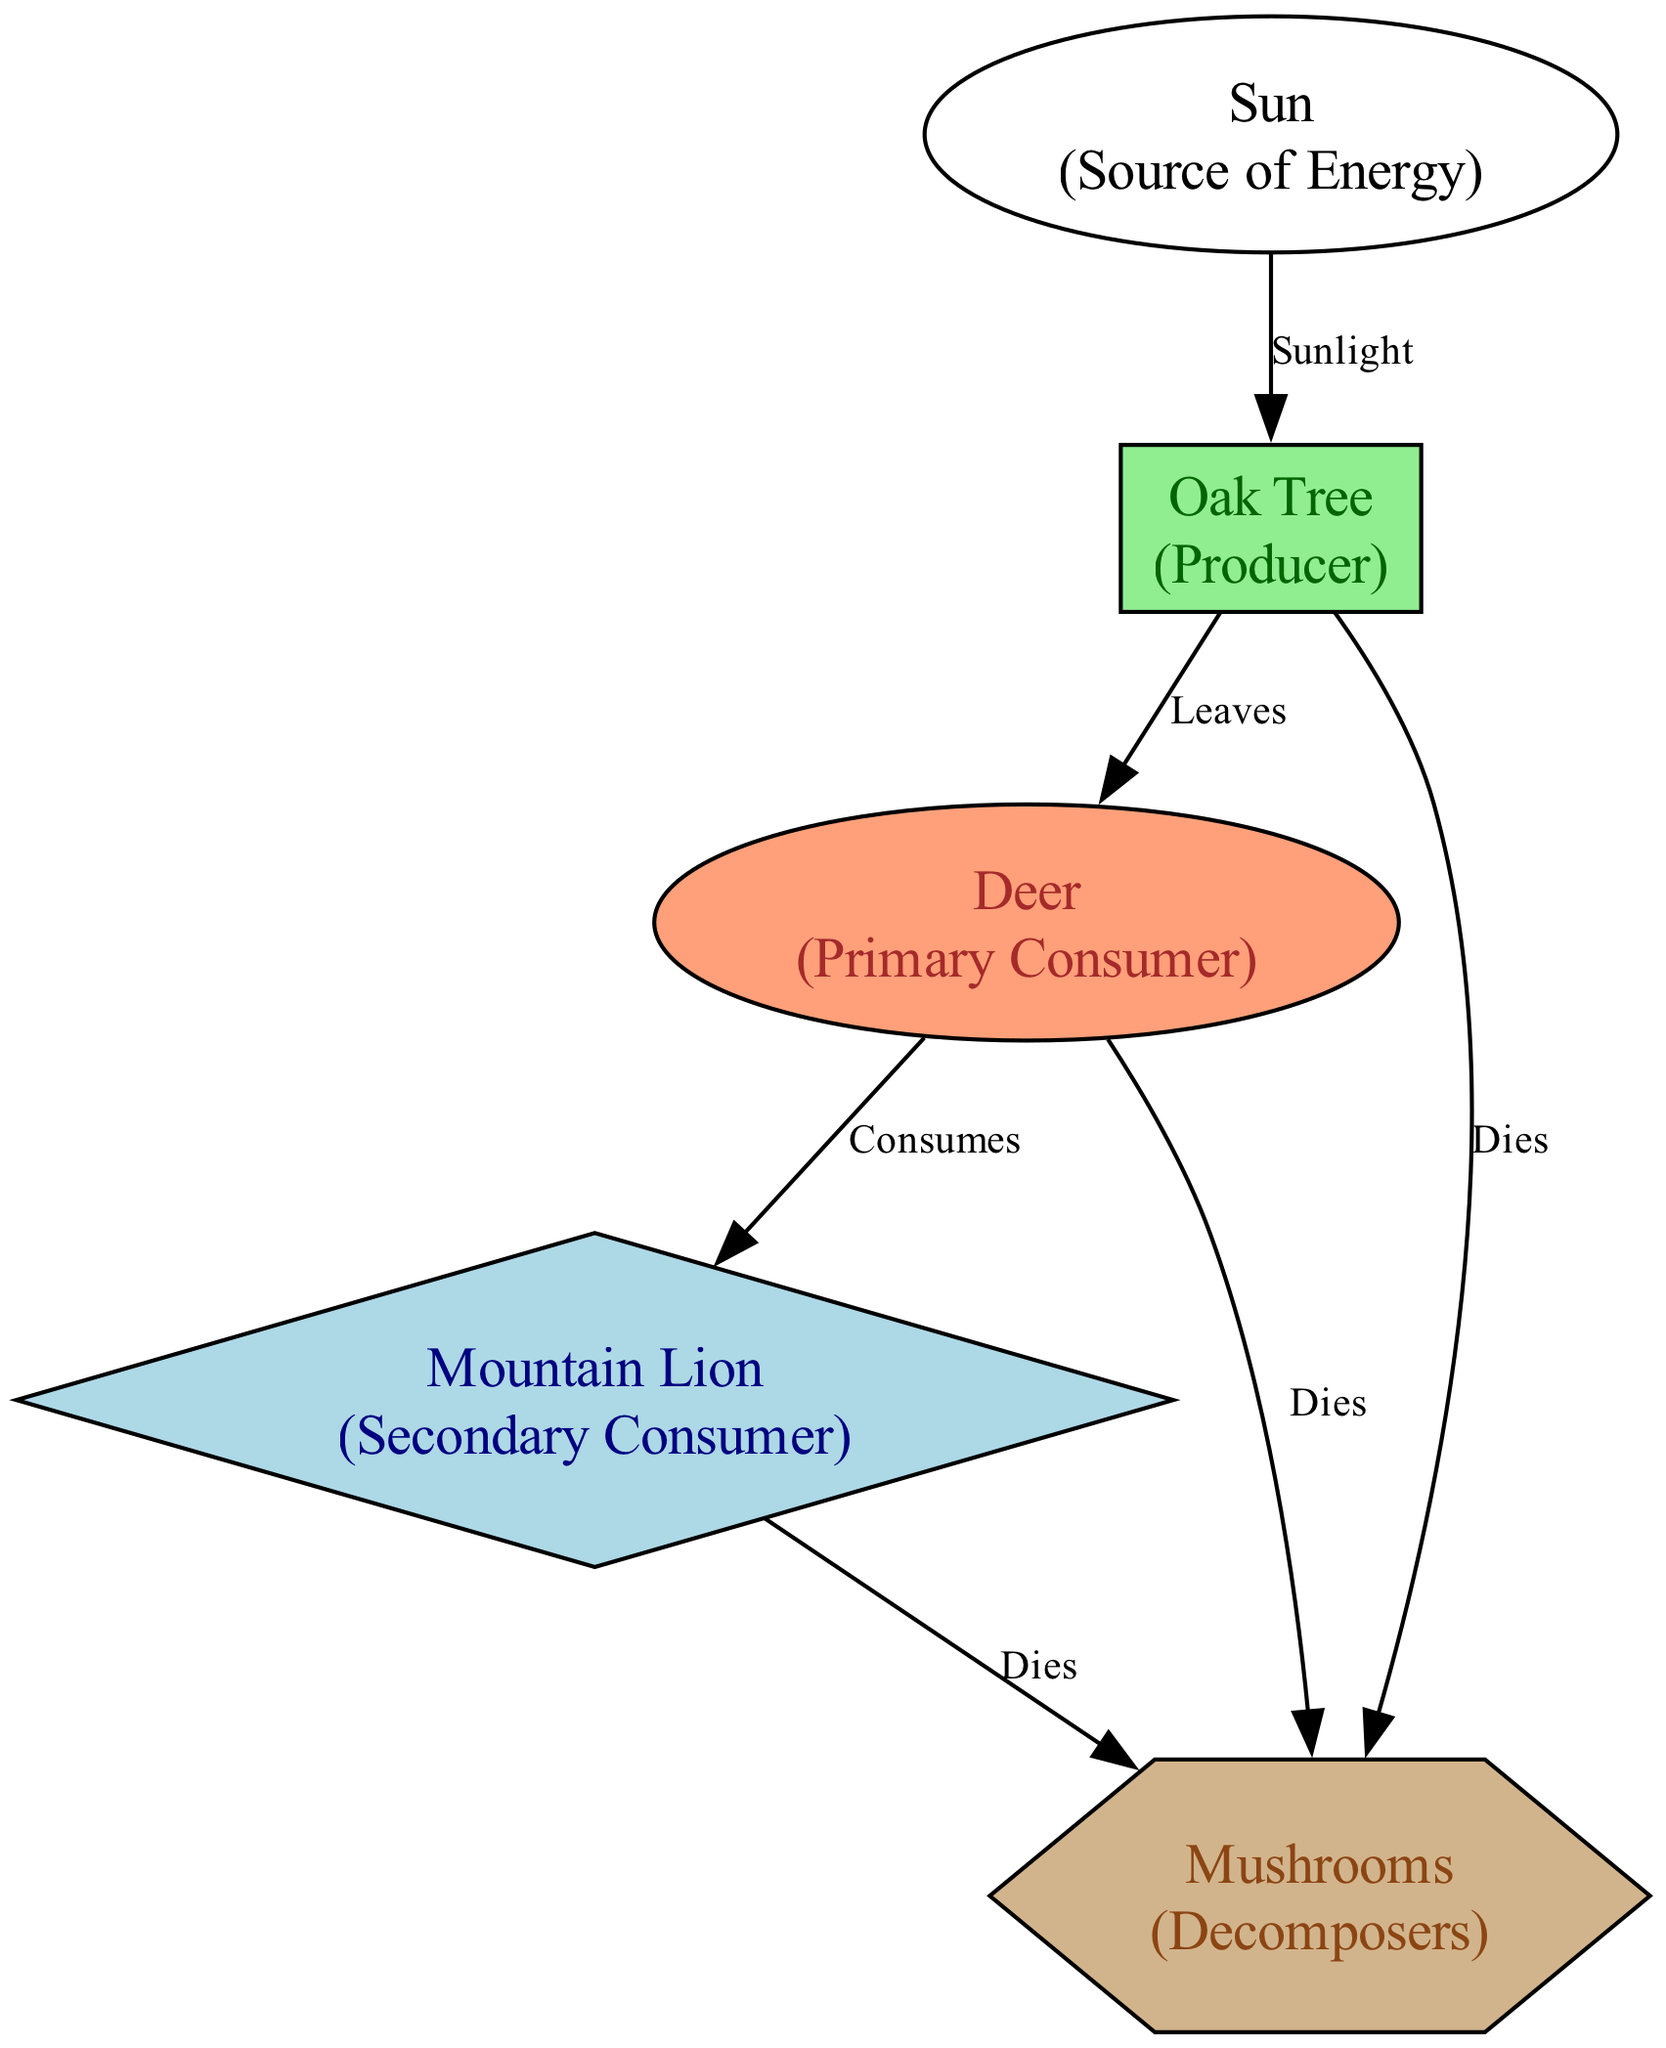What is the primary source of energy in this food chain? The diagram indicates that the Sun is the primary source of energy, as shown at the top of the food chain. It directly feeds into the producer, Oak Tree, through sunlight labeled as energy input.
Answer: Sun How many producers are in the diagram? In the diagram, there is one producer, which is the Oak Tree. This can be identified by the nodes present; the Oak Tree is labeled as a producer, and it's the only one shown in the food chain.
Answer: 1 What do primary consumers eat in this ecosystem? The primary consumer, Deer, consumes the leaves of the Oak Tree. This relationship is indicated by the edge that connects the Oak Tree to the Deer, labeled as "Leaves."
Answer: Leaves Who is the secondary consumer in this food chain? The diagram shows that the Mountain Lion is the secondary consumer, as depicted by the node labeled as such. It consumes the primary consumer (Deer) as illustrated by the directed edge from Deer to Mountain Lion.
Answer: Mountain Lion How many decomposers are represented in this ecosystem? There is one decomposer shown in the diagram, which is Mushrooms. It is listed as the only decomposer in the nodes and also indicated by the relationships it has with other organisms in the food chain.
Answer: 1 What are two ways that primary consumers contribute to the decomposition process? The diagram highlights two ways: First, the Deer dies, contributing to the decomposition process, indicated by the edge connecting Deer to Mushrooms labeled as "Dies." Second, the Oak Tree also dies and contributes to the decomposing process as indicated by the edge from Oak Tree to Mushrooms.
Answer: Dies Which relationship involves the transfer of energy from the sun to the producer? The relationship is shown with the edge labeled "Sunlight," connecting the Sun to the Oak Tree. This indicates that energy from the Sun is transferred to the Oak Tree, which is the producer.
Answer: Sunlight What happens to the secondary consumer when it dies in this ecosystem? When the Mountain Lion dies, it becomes part of the decomposing process, which is shown in the diagram by the directed edge to Mushrooms labeled "Dies." This indicates that the energy from the Mountain Lion is transferred to the decomposer.
Answer: Dies 